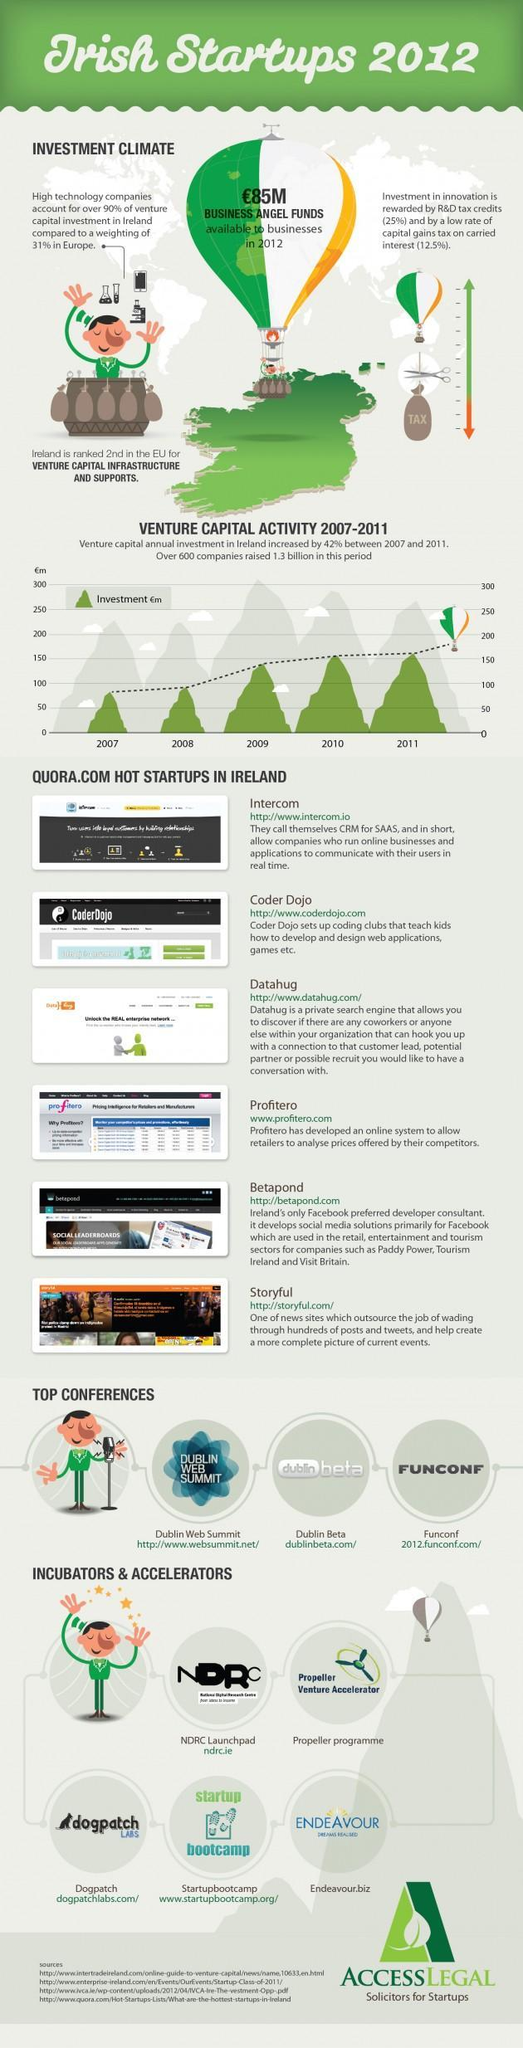Under which category of organizations is Startupbootcamp listed?
Answer the question with a short phrase. incubators & accelerators For how many years between 2007-2011 was the investment above 150 million pounds? 2 Which company is listed third in the list of Quora.com hot startups in Ireland? Datahug What is listed second among the top conferences? Dublin Beta 